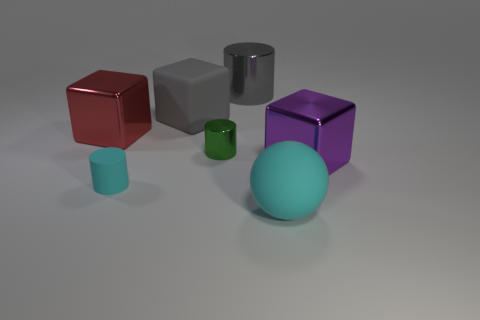Subtract 1 cylinders. How many cylinders are left? 2 Add 1 shiny spheres. How many objects exist? 8 Subtract all balls. How many objects are left? 6 Subtract 0 brown cylinders. How many objects are left? 7 Subtract all small shiny cylinders. Subtract all gray metallic objects. How many objects are left? 5 Add 7 small cyan rubber cylinders. How many small cyan rubber cylinders are left? 8 Add 3 big gray matte cubes. How many big gray matte cubes exist? 4 